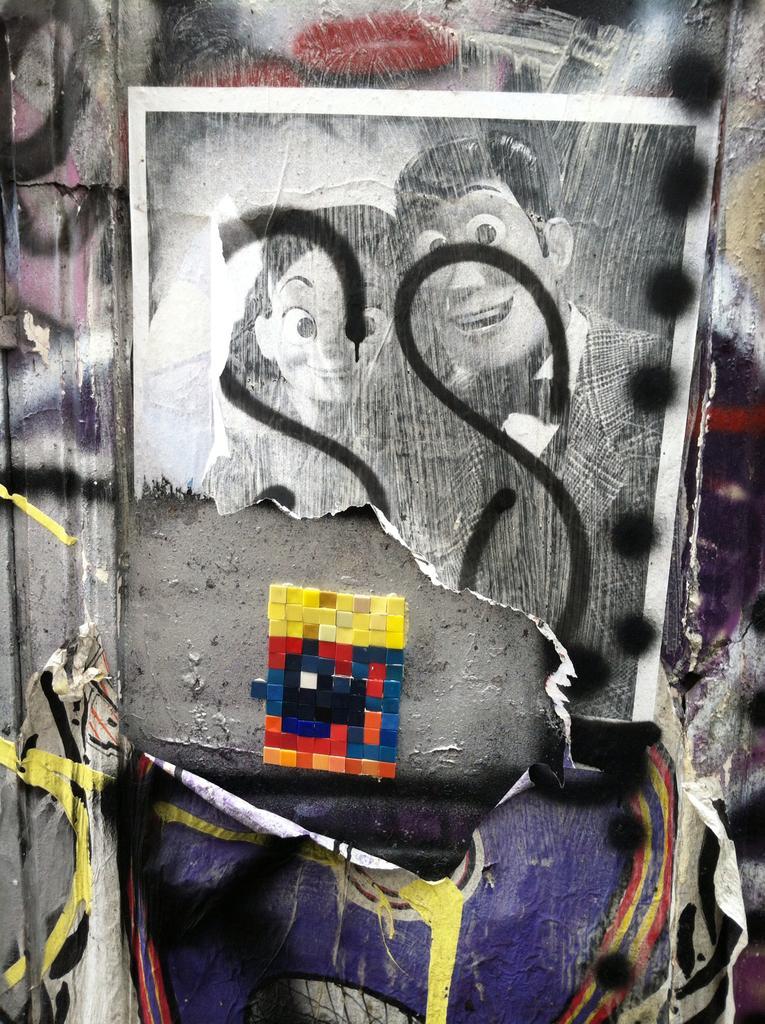How would you summarize this image in a sentence or two? In this picture, we see the poster in black and white is pasted on the wall. This picture contains a wall graffiti. In the middle of the picture, we see the small blocks in red, orange, blue, yellow and black color. 